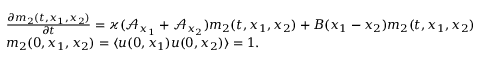Convert formula to latex. <formula><loc_0><loc_0><loc_500><loc_500>\begin{array} { r l } & { \frac { \partial m _ { 2 } ( t , x _ { 1 } , x _ { 2 } ) } { \partial t } = \varkappa ( \mathcal { A } _ { x _ { 1 } } + \mathcal { A } _ { x _ { 2 } } ) m _ { 2 } ( t , x _ { 1 } , x _ { 2 } ) + B ( x _ { 1 } - x _ { 2 } ) m _ { 2 } ( t , x _ { 1 } , x _ { 2 } ) } \\ & { m _ { 2 } ( 0 , x _ { 1 } , x _ { 2 } ) = \langle u ( 0 , x _ { 1 } ) u ( 0 , x _ { 2 } ) \rangle = 1 . } \end{array}</formula> 